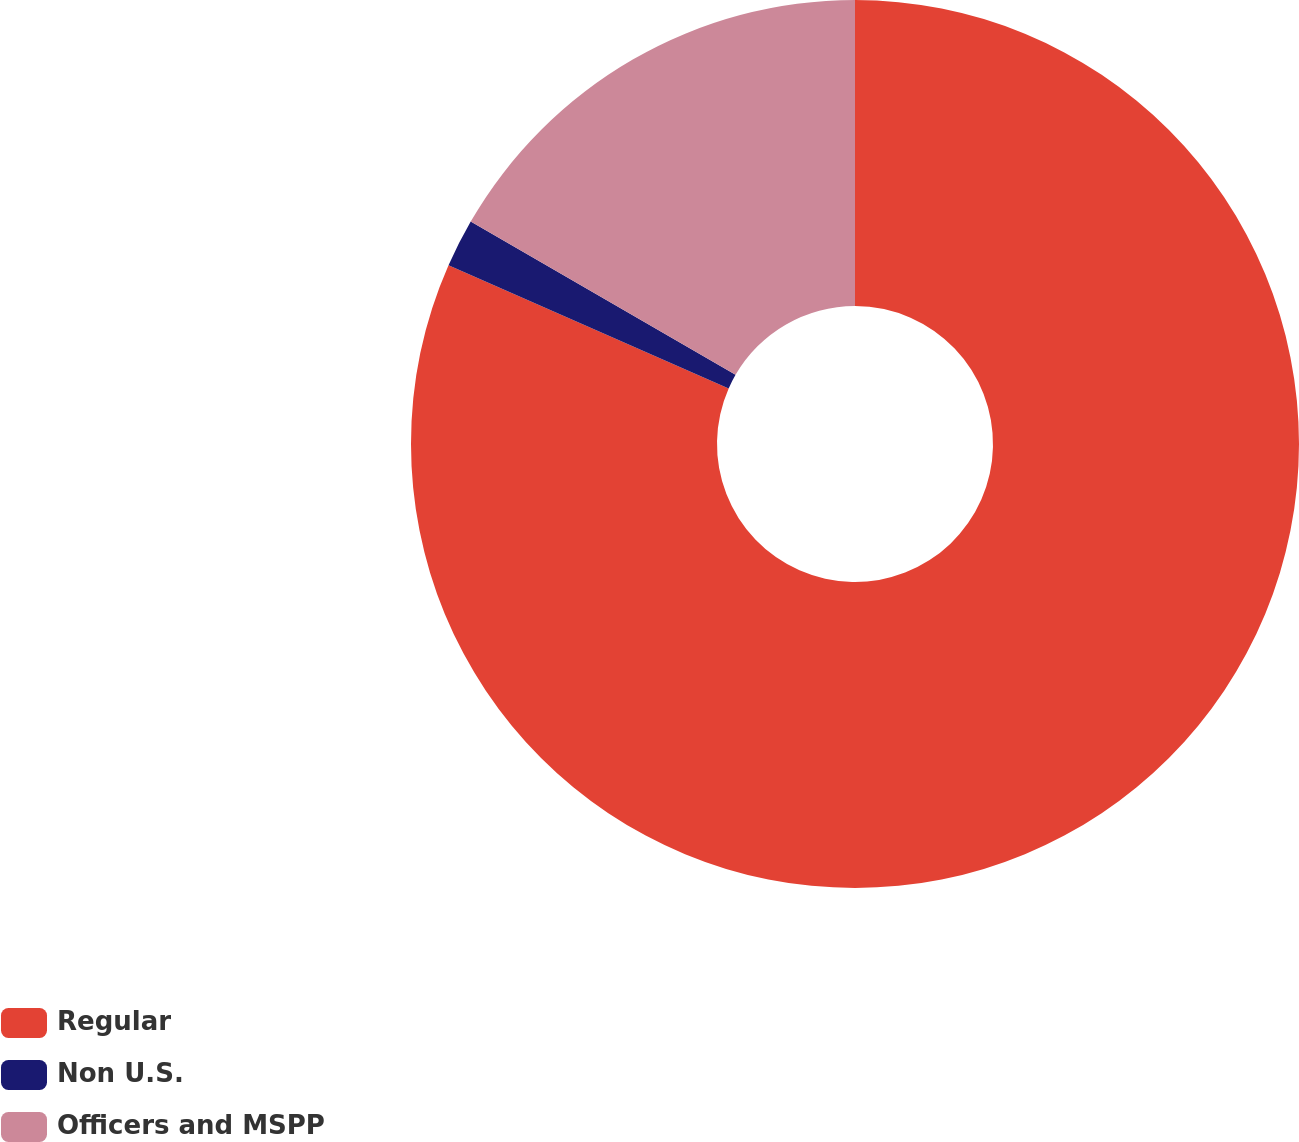Convert chart. <chart><loc_0><loc_0><loc_500><loc_500><pie_chart><fcel>Regular<fcel>Non U.S.<fcel>Officers and MSPP<nl><fcel>81.59%<fcel>1.76%<fcel>16.65%<nl></chart> 